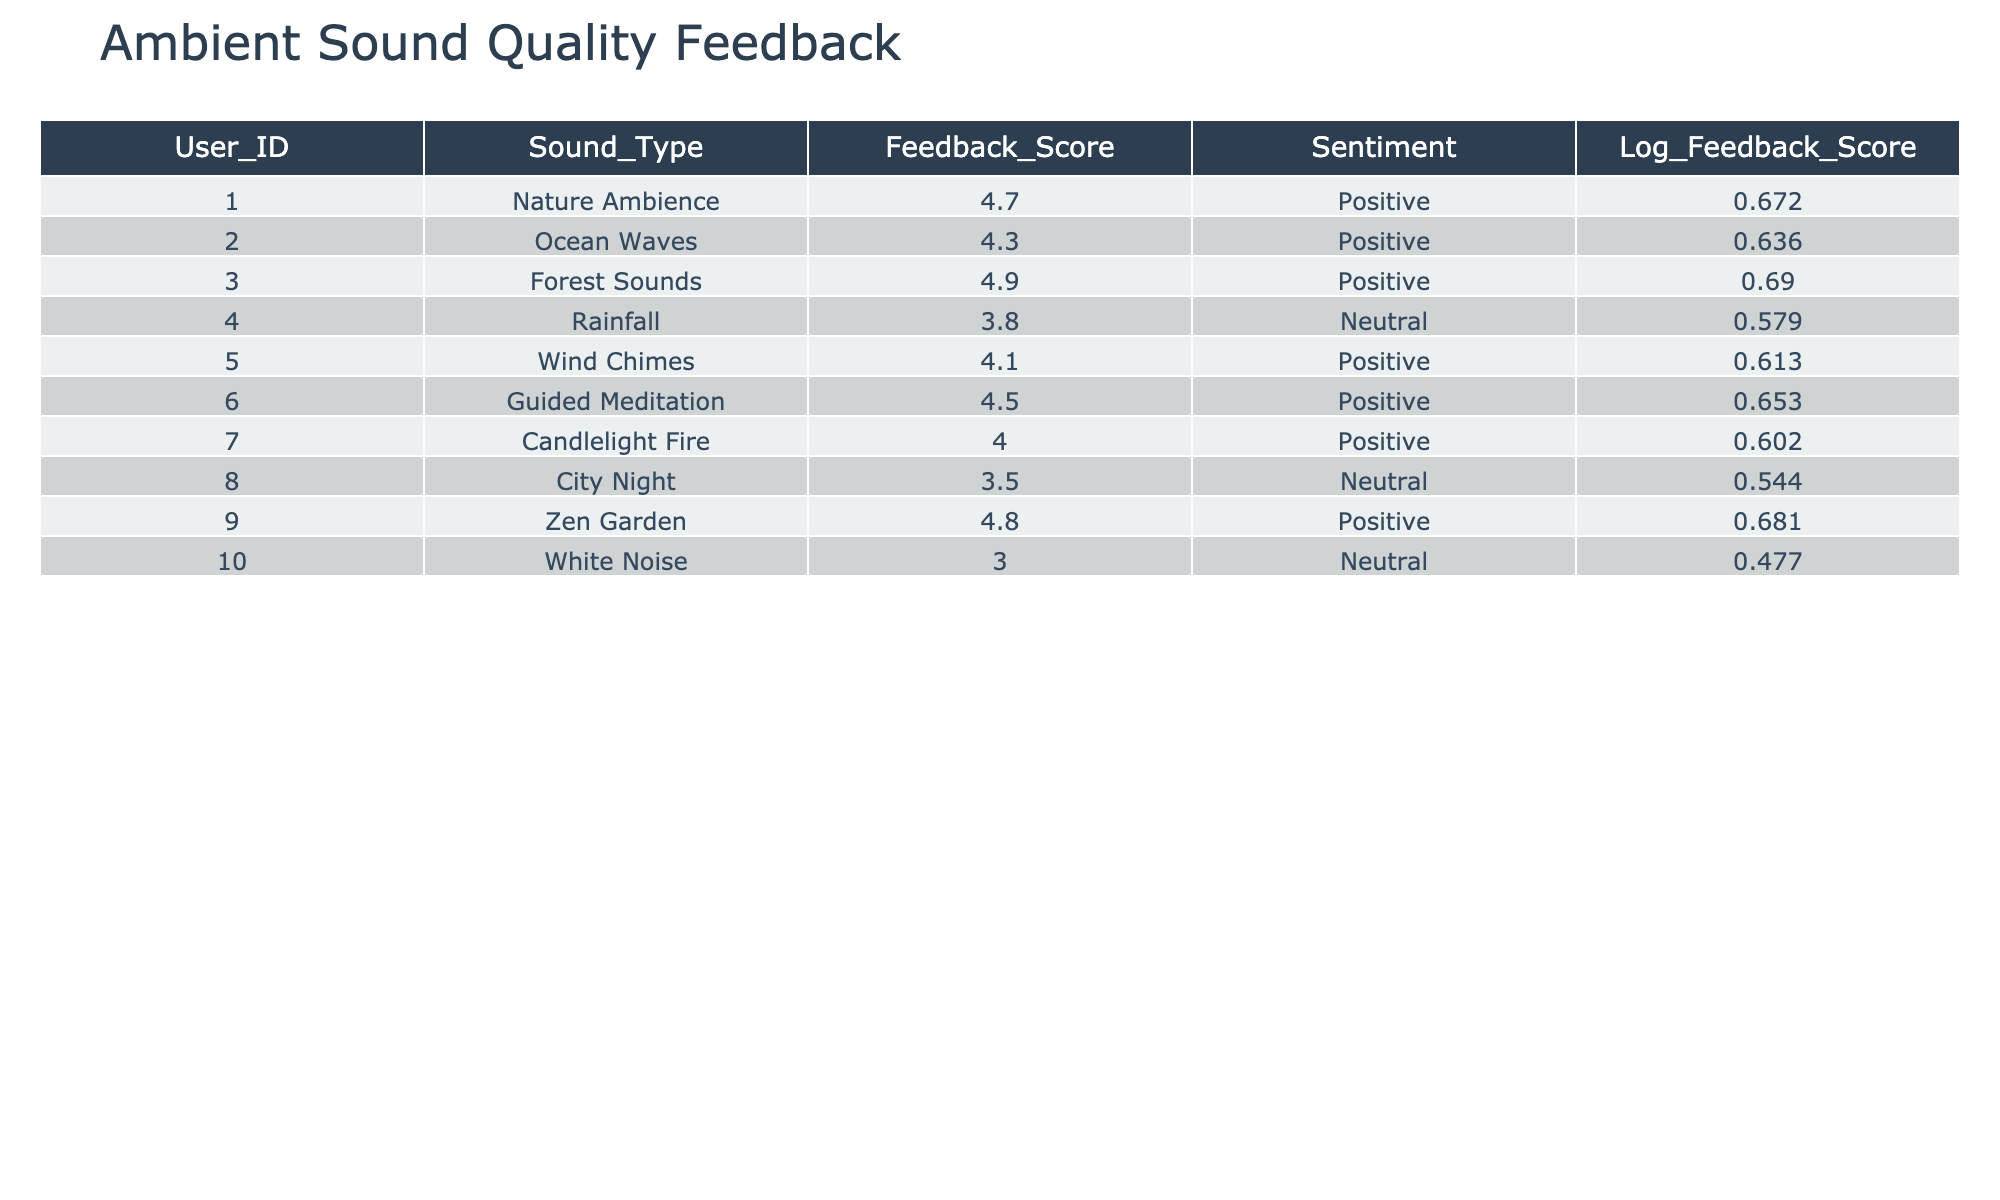What is the feedback score for Zen Garden? Referring to the table, the row corresponding to Zen Garden shows a feedback score of 4.8.
Answer: 4.8 How many sound types have a positive sentiment? Counting the rows with a positive sentiment, we find that Nature Ambience, Ocean Waves, Forest Sounds, Wind Chimes, Guided Meditation, Candlelight Fire, and Zen Garden are all positive, totaling 7 sound types.
Answer: 7 What is the average feedback score of the Neutral sentiment sound types? The sound types with a Neutral sentiment are Rainfall, City Night, and White Noise, with scores of 3.8, 3.5, and 3.0 respectively. Adding these gives 3.8 + 3.5 + 3.0 = 10.3, and dividing by 3 (the number of neutral sound types) gives an average of 10.3 / 3 ≈ 3.43.
Answer: Approximately 3.43 Is the feedback score for Ocean Waves higher than that for Candlelight Fire? Comparing the values, Ocean Waves has a feedback score of 4.3, while Candlelight Fire has a score of 4.0. Since 4.3 is greater than 4.0, the statement is true.
Answer: Yes What is the difference between the highest and lowest feedback scores? The highest score is 4.9 (Forest Sounds) and the lowest is 3.0 (White Noise). The difference is 4.9 - 3.0 = 1.9.
Answer: 1.9 If we consider the feedback scores only for the Positive sentiment group, what is the highest score? Among the positive sentiment sound types, the scores are 4.7 (Nature Ambience), 4.3 (Ocean Waves), 4.9 (Forest Sounds), 4.1 (Wind Chimes), 4.5 (Guided Meditation), 4.0 (Candlelight Fire), and 4.8 (Zen Garden). The highest is 4.9.
Answer: 4.9 Which sound type has the second highest feedback score? The sound types in descending order of their feedback scores are: 4.9 (Forest Sounds), 4.8 (Zen Garden), 4.7 (Nature Ambience), etc. Therefore, the second highest score is 4.8, corresponding to Zen Garden.
Answer: Zen Garden Are all feedback scores above 3.0? Checking each feedback score, Rainfall (3.8), City Night (3.5), and White Noise (3.0) show scores equal to or above 3.0. Hence, yes, all scores are above 3.0.
Answer: Yes 